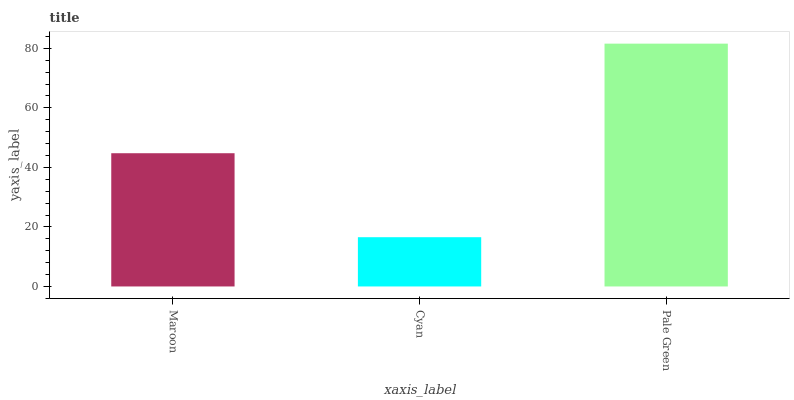Is Cyan the minimum?
Answer yes or no. Yes. Is Pale Green the maximum?
Answer yes or no. Yes. Is Pale Green the minimum?
Answer yes or no. No. Is Cyan the maximum?
Answer yes or no. No. Is Pale Green greater than Cyan?
Answer yes or no. Yes. Is Cyan less than Pale Green?
Answer yes or no. Yes. Is Cyan greater than Pale Green?
Answer yes or no. No. Is Pale Green less than Cyan?
Answer yes or no. No. Is Maroon the high median?
Answer yes or no. Yes. Is Maroon the low median?
Answer yes or no. Yes. Is Pale Green the high median?
Answer yes or no. No. Is Cyan the low median?
Answer yes or no. No. 